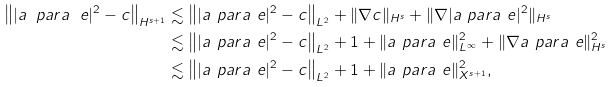<formula> <loc_0><loc_0><loc_500><loc_500>\left \| | a _ { \ } p a r a ^ { \ } e | ^ { 2 } - c \right \| _ { H ^ { s + 1 } } & \lesssim \left \| | a _ { \ } p a r a ^ { \ } e | ^ { 2 } - c \right \| _ { L ^ { 2 } } + \| \nabla c \| _ { H ^ { s } } + \| \nabla | a _ { \ } p a r a ^ { \ } e | ^ { 2 } \| _ { H ^ { s } } \\ & \lesssim \left \| | a _ { \ } p a r a ^ { \ } e | ^ { 2 } - c \right \| _ { L ^ { 2 } } + 1 + \| a _ { \ } p a r a ^ { \ } e \| _ { L ^ { \infty } } ^ { 2 } + \| \nabla a _ { \ } p a r a ^ { \ } e \| _ { H ^ { s } } ^ { 2 } \\ & \lesssim \left \| | a _ { \ } p a r a ^ { \ } e | ^ { 2 } - c \right \| _ { L ^ { 2 } } + 1 + \| a _ { \ } p a r a ^ { \ } e \| _ { X ^ { s + 1 } } ^ { 2 } ,</formula> 